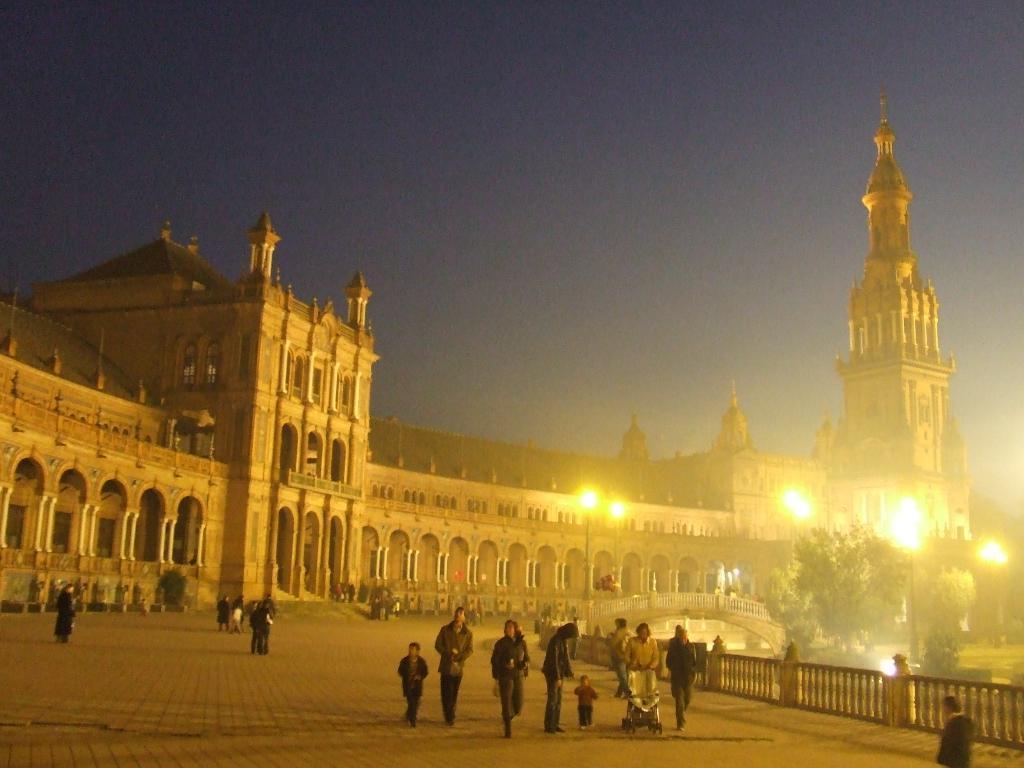Can you describe this image briefly? This picture is clicked outside. In the center we can see the group of persons and we can see the building and a spire and we can see the lights, trees and many other objects. In the background we can see the sky. 